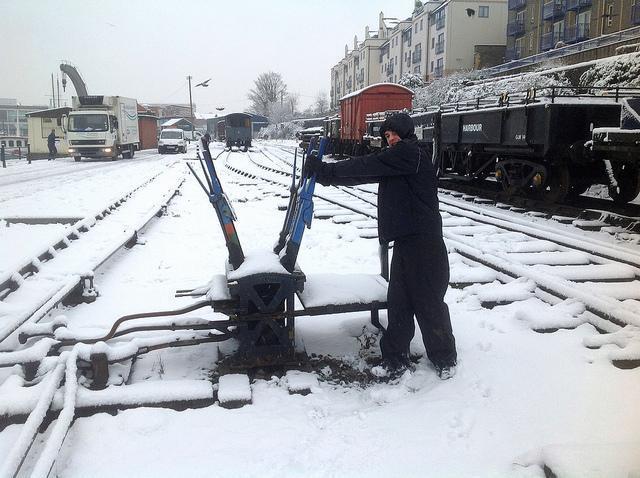How many trains can be seen?
Give a very brief answer. 2. 